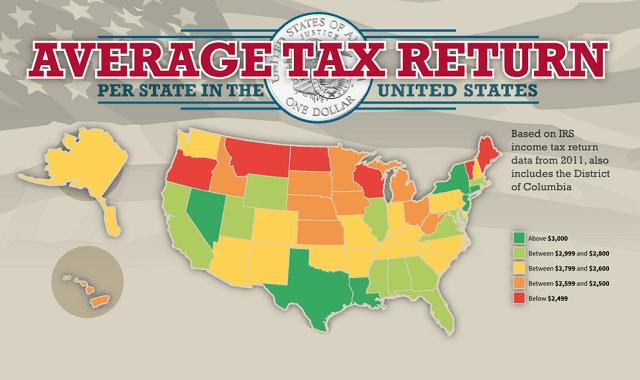Identify some key points in this picture. The large island in the northwest is yellow in color. The average tax return for a small group of islands in the south west region is between $2,599 and $2,500. According to the data, four, five, or six states have average tax returns below $2,499. 